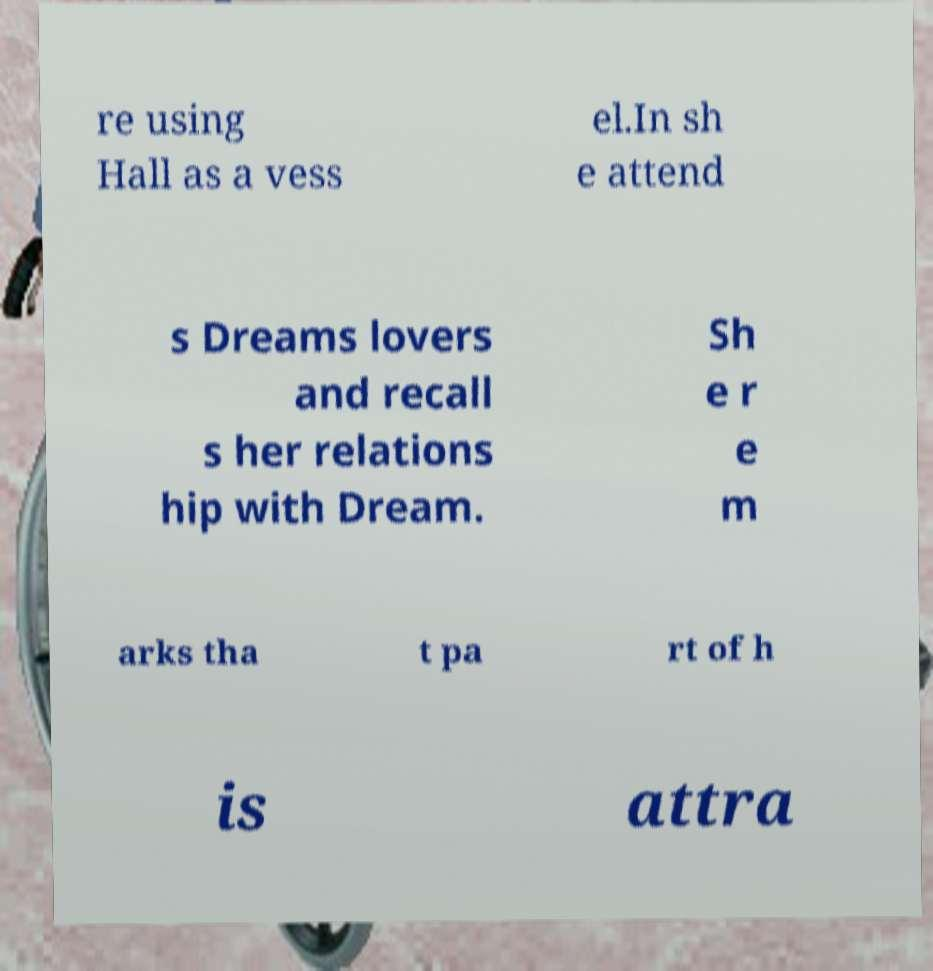Please read and relay the text visible in this image. What does it say? re using Hall as a vess el.In sh e attend s Dreams lovers and recall s her relations hip with Dream. Sh e r e m arks tha t pa rt of h is attra 